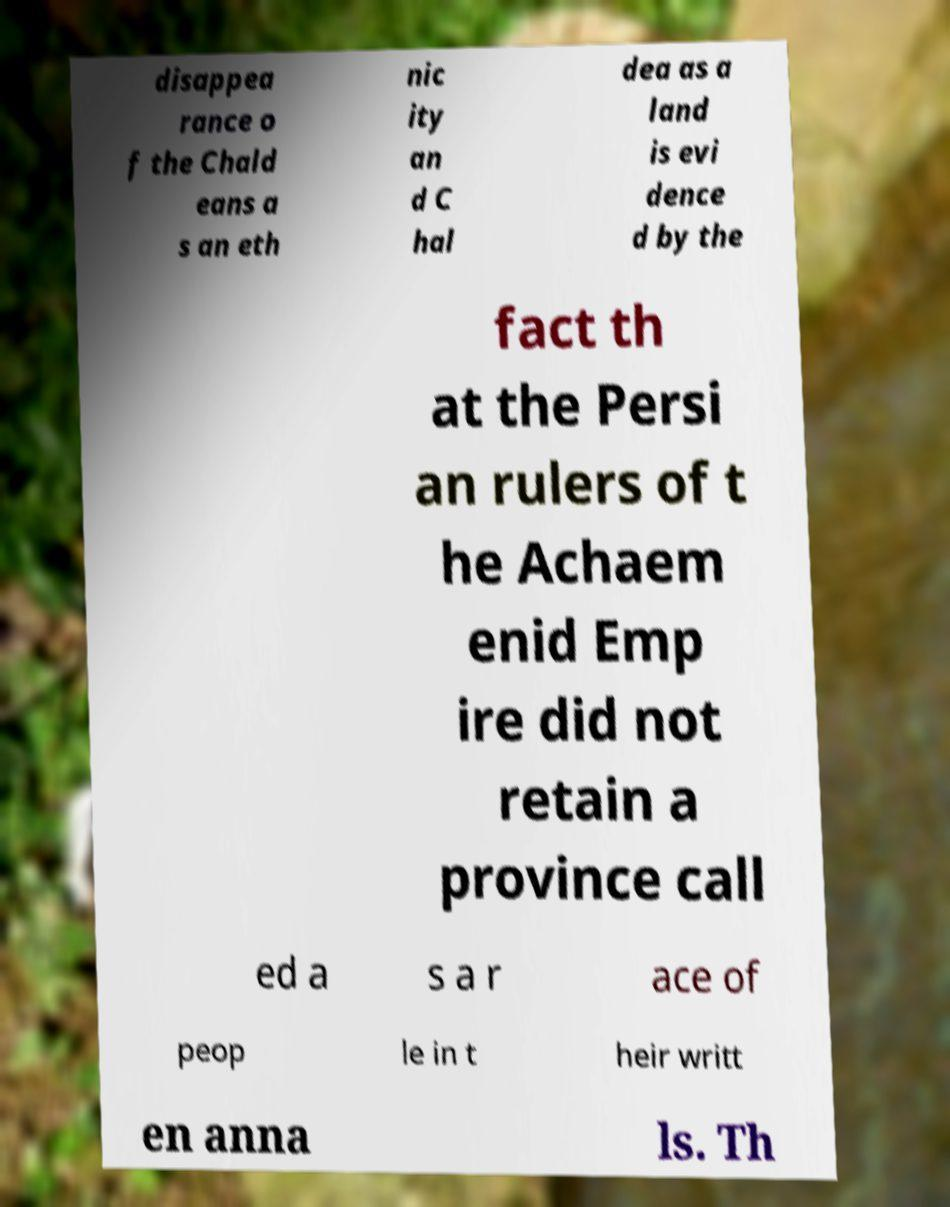Could you assist in decoding the text presented in this image and type it out clearly? disappea rance o f the Chald eans a s an eth nic ity an d C hal dea as a land is evi dence d by the fact th at the Persi an rulers of t he Achaem enid Emp ire did not retain a province call ed a s a r ace of peop le in t heir writt en anna ls. Th 